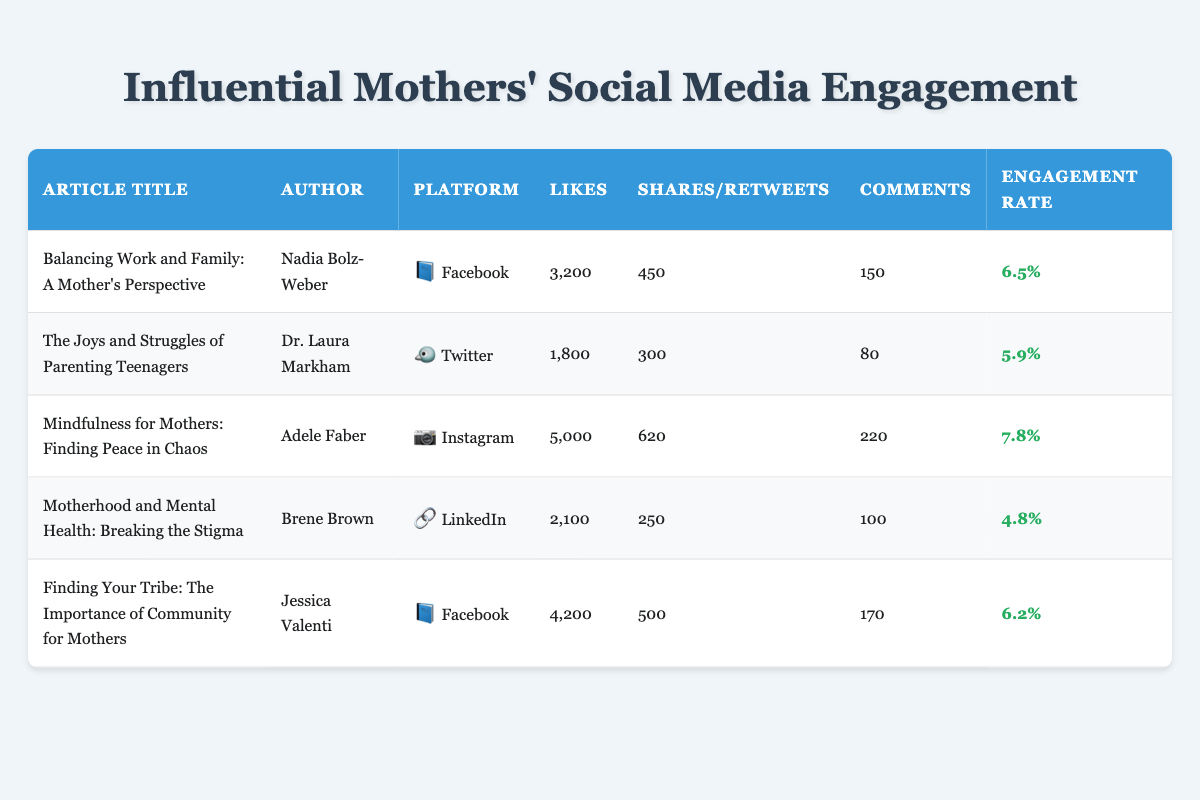What is the title of the article with the highest engagement rate? To find the article with the highest engagement rate, I look through the engagement rate column. The highest value is 7.8%, which corresponds to the article titled "Mindfulness for Mothers: Finding Peace in Chaos."
Answer: Mindfulness for Mothers: Finding Peace in Chaos Which article received the most likes on Facebook? The articles on Facebook are "Balancing Work and Family: A Mother’s Perspective" with 3200 likes and "Finding Your Tribe: The Importance of Community for Mothers" with 4200 likes. The article with the most likes is therefore "Finding Your Tribe: The Importance of Community for Mothers."
Answer: Finding Your Tribe: The Importance of Community for Mothers Who is the author of the article titled "Motherhood and Mental Health: Breaking the Stigma"? By searching the table for the title "Motherhood and Mental Health: Breaking the Stigma," I can find the corresponding author listed, which is Brene Brown.
Answer: Brene Brown What platform did the article titled "The Joys and Struggles of Parenting Teenagers" get published on? The table lists "The Joys and Struggles of Parenting Teenagers" under the platform column, which is Twitter.
Answer: Twitter What is the total number of shares/retweets for all articles combined? To find the total number of shares/retweets, I sum the shares/retweets for all articles: 450 + 300 + 620 + 250 + 500 = 2120.
Answer: 2120 Is the engagement rate for "Mindfulness for Mothers: Finding Peace in Chaos" higher than 6%? The engagement rate for "Mindfulness for Mothers: Finding Peace in Chaos" is 7.8%, which is indeed higher than 6%.
Answer: Yes Which article has the least number of comments among all articles? I need to look at the comments column across all articles. The least number is 80, which corresponds to "The Joys and Struggles of Parenting Teenagers" by Dr. Laura Markham.
Answer: The Joys and Struggles of Parenting Teenagers Calculate the average engagement rate of the articles listed. The engagement rates are 6.5, 5.9, 7.8, 4.8, and 6.2. Summing these gives 6.5 + 5.9 + 7.8 + 4.8 + 6.2 = 31.2. Dividing this by the number of articles (5), the average engagement rate is 31.2 / 5 = 6.24.
Answer: 6.24 Which platform had the highest number of likes in total? I need to look at the likes for each article by platform: Facebook has 3200 + 4200 = 7400, Twitter has 1800, Instagram has 5000, and LinkedIn has 2100. Facebook has the highest total with 7400 likes.
Answer: Facebook 